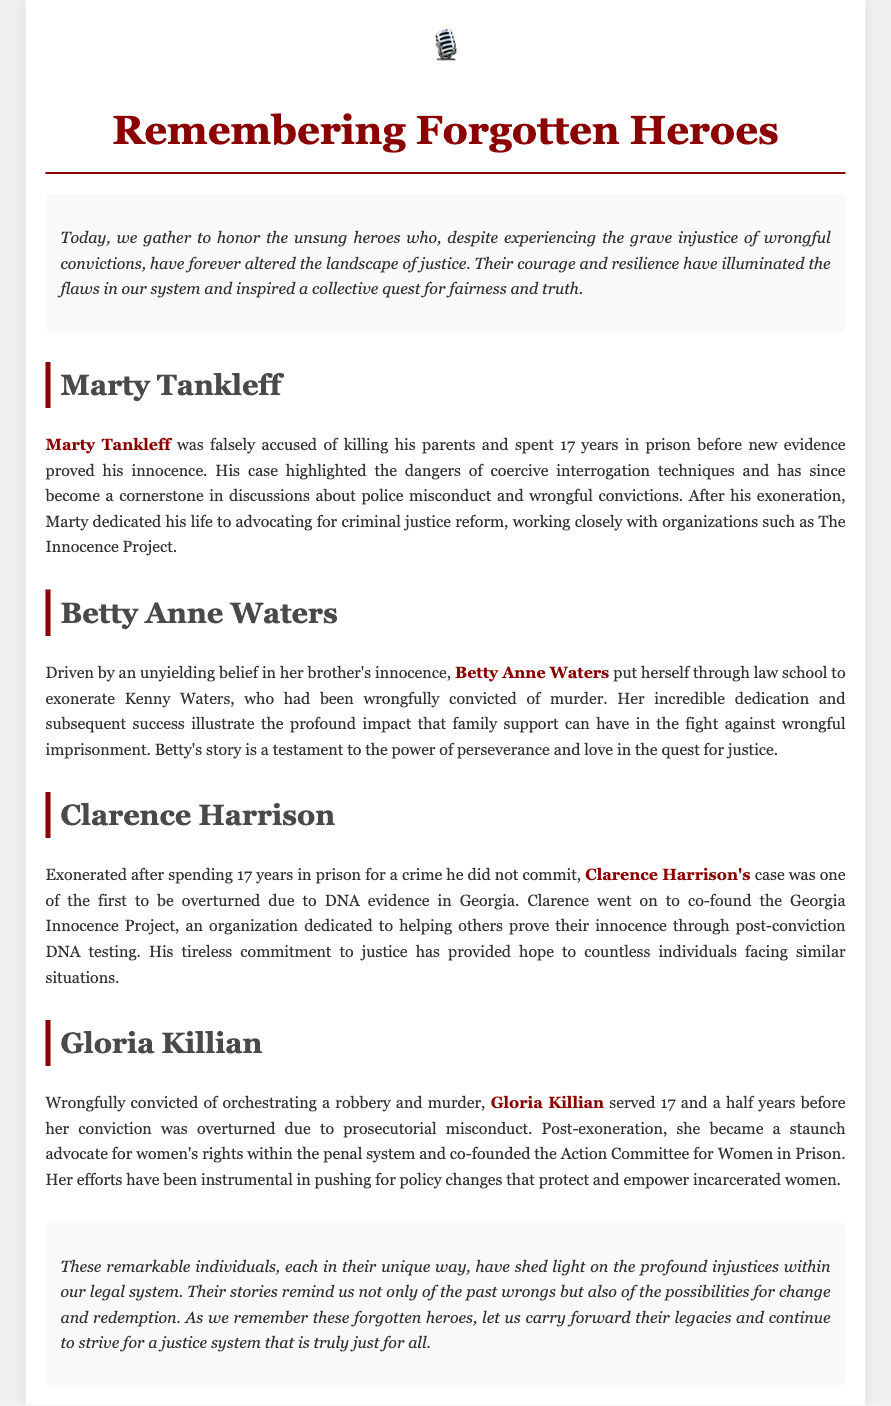What is the title of the document? The title is prominently displayed at the top of the document, stating the focus on forgotten heroes in the justice landscape.
Answer: Remembering Forgotten Heroes How many years did Marty Tankleff spend in prison? The document states that Marty Tankleff spent 17 years in prison before his exoneration.
Answer: 17 years Who put herself through law school to exonerate her brother? The document highlights Betty Anne Waters as the individual who undertook this effort for her brother.
Answer: Betty Anne Waters Which organization did Clarence Harrison co-found? The text mentions that Clarence Harrison co-founded the Georgia Innocence Project after his exoneration.
Answer: Georgia Innocence Project What impact did Gloria Killian have after her exoneration? The document describes Gloria Killian's role as a staunch advocate for women's rights within the penal system after her release.
Answer: Women's rights advocacy What is a central theme of this eulogy? The overarching theme involves recognizing the significant contributions of lesser-known exonerees to justice reform.
Answer: Justice reform Which exoneree's case became a cornerstone in discussions about police misconduct? The text indicates that Marty Tankleff's case is significant in discussions about police misconduct.
Answer: Marty Tankleff What did Betty Anne Waters demonstrate through her actions? The document emphasizes Betty Anne Waters' demonstration of perseverance and love in the fight for justice.
Answer: Perseverance and love How many exonerees are specifically highlighted in the document? There are four exonerees detailed in the eulogy, focusing on their stories and contributions.
Answer: Four 